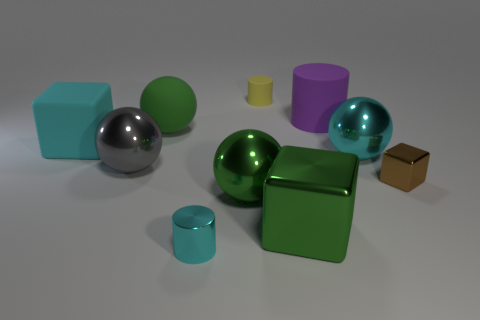How many small yellow rubber things are the same shape as the large purple rubber thing?
Your answer should be very brief. 1. Is the material of the purple thing the same as the green thing behind the brown cube?
Your response must be concise. Yes. There is a green sphere that is made of the same material as the gray sphere; what is its size?
Give a very brief answer. Large. There is a ball that is to the right of the large purple rubber cylinder; what is its size?
Your answer should be very brief. Large. How many brown things have the same size as the metal cylinder?
Your answer should be compact. 1. What is the size of the cylinder that is the same color as the large rubber cube?
Give a very brief answer. Small. Is there a sphere of the same color as the rubber block?
Provide a succinct answer. Yes. The matte cylinder that is the same size as the cyan matte object is what color?
Your response must be concise. Purple. Do the shiny cylinder and the big matte thing that is in front of the large green matte sphere have the same color?
Offer a terse response. Yes. The rubber ball is what color?
Keep it short and to the point. Green. 